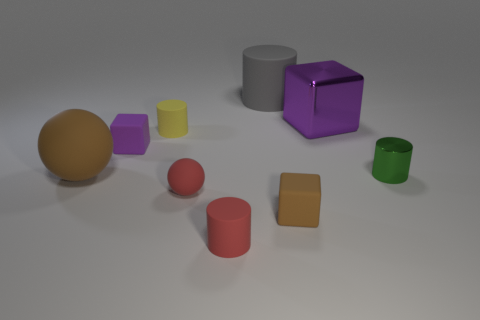Subtract all brown cubes. How many cubes are left? 2 Subtract all small purple rubber blocks. How many blocks are left? 2 Subtract 0 cyan cubes. How many objects are left? 9 Subtract all cubes. How many objects are left? 6 Subtract 3 cubes. How many cubes are left? 0 Subtract all green blocks. Subtract all red spheres. How many blocks are left? 3 Subtract all blue cylinders. How many brown balls are left? 1 Subtract all large gray cylinders. Subtract all small purple matte cubes. How many objects are left? 7 Add 6 large purple things. How many large purple things are left? 7 Add 9 small green metallic objects. How many small green metallic objects exist? 10 